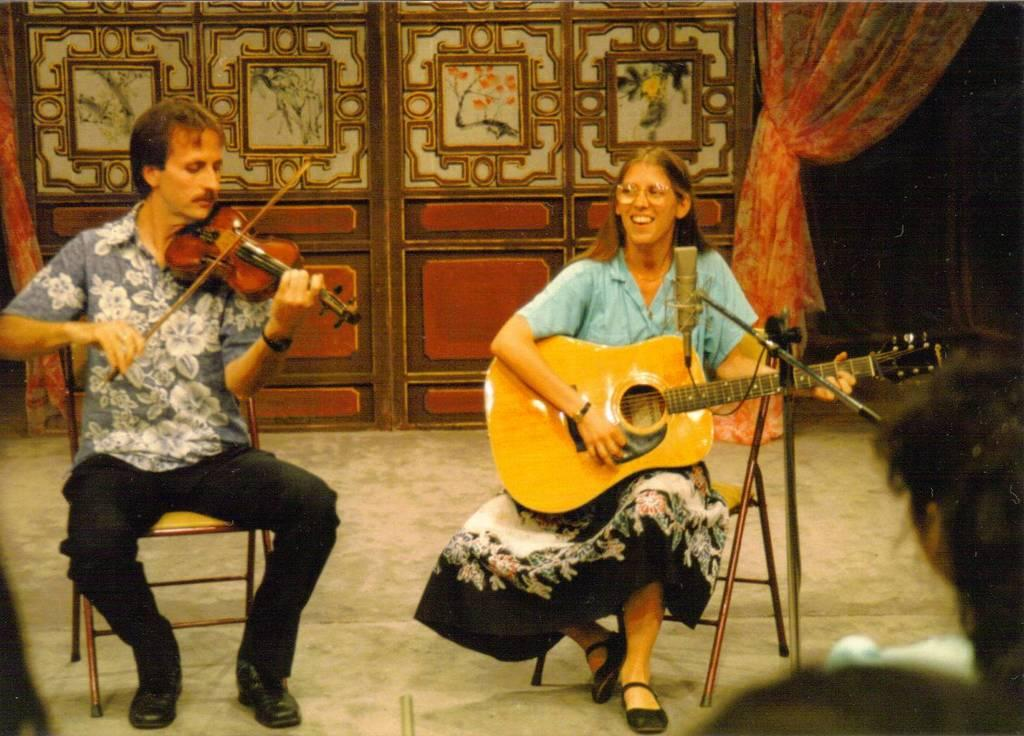What is the man in the image doing? The man is sitting in a chair and playing a violin in the image. What is the woman in the image doing? The woman is sitting in a chair and playing a violin in the image. What can be seen in the background of the image? There is a curtain in the background of the image. What type of pest can be seen crawling on the violin in the image? There are no pests visible in the image, and no pests are interacting with the violins. 